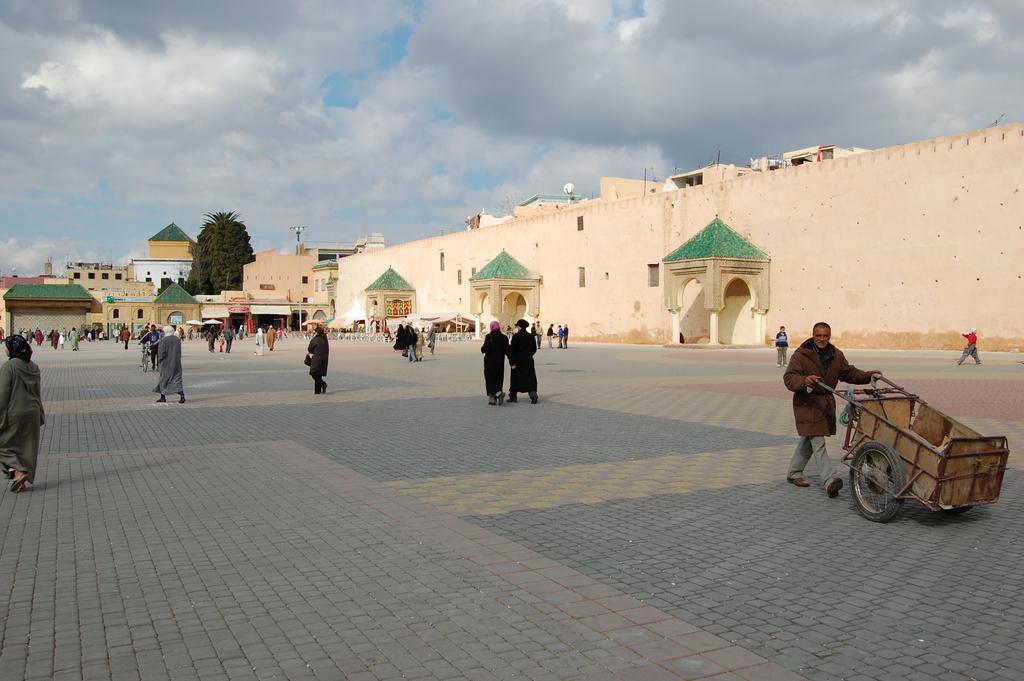How would you summarize this image in a sentence or two? In the foreground of the picture we can see people and pavement. On the right we can see a person with a cart. In the middle of the picture there are buildings, trees, streetlight, people and various objects. At the top it is sky. The sky is cloudy. 